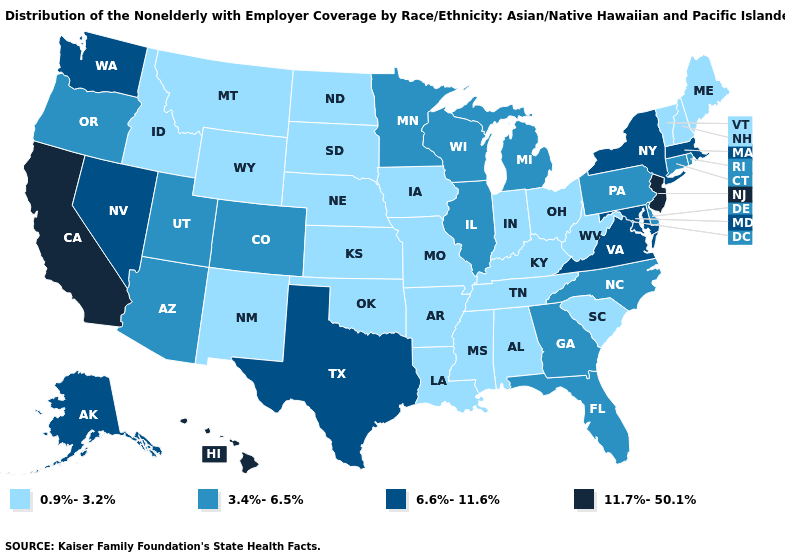What is the value of New Jersey?
Concise answer only. 11.7%-50.1%. Does New Mexico have the lowest value in the USA?
Keep it brief. Yes. What is the value of Nevada?
Give a very brief answer. 6.6%-11.6%. Does Idaho have the lowest value in the West?
Give a very brief answer. Yes. What is the highest value in the USA?
Short answer required. 11.7%-50.1%. Which states have the lowest value in the Northeast?
Short answer required. Maine, New Hampshire, Vermont. Does Georgia have the lowest value in the USA?
Short answer required. No. What is the value of Minnesota?
Concise answer only. 3.4%-6.5%. What is the value of Indiana?
Short answer required. 0.9%-3.2%. What is the highest value in the USA?
Keep it brief. 11.7%-50.1%. What is the highest value in states that border Rhode Island?
Quick response, please. 6.6%-11.6%. Name the states that have a value in the range 3.4%-6.5%?
Quick response, please. Arizona, Colorado, Connecticut, Delaware, Florida, Georgia, Illinois, Michigan, Minnesota, North Carolina, Oregon, Pennsylvania, Rhode Island, Utah, Wisconsin. What is the value of Illinois?
Short answer required. 3.4%-6.5%. What is the value of Maryland?
Keep it brief. 6.6%-11.6%. What is the highest value in states that border New York?
Quick response, please. 11.7%-50.1%. 